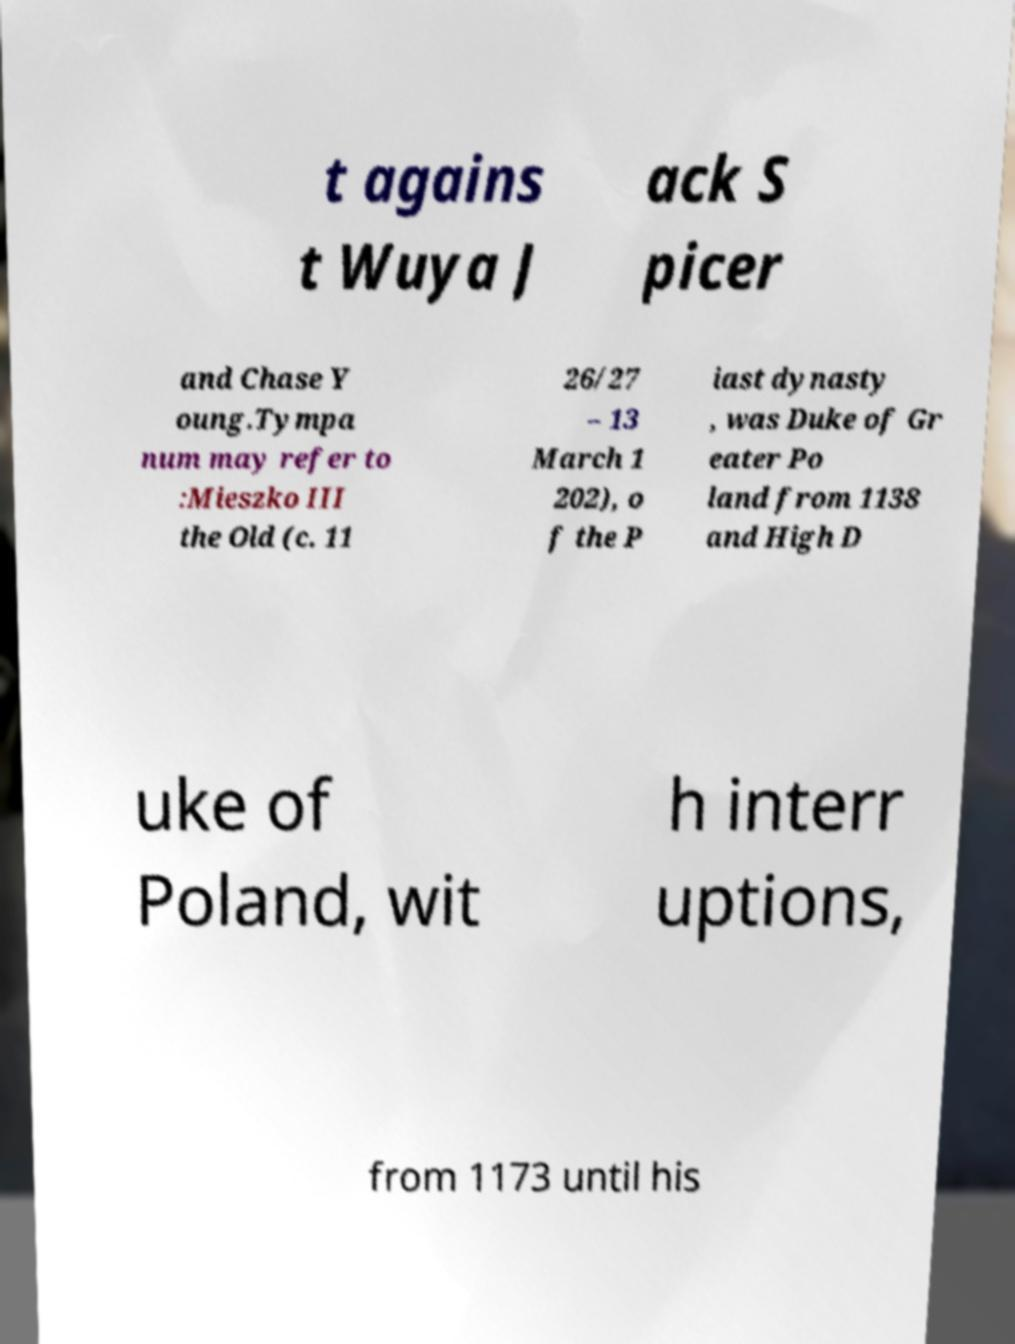Please identify and transcribe the text found in this image. t agains t Wuya J ack S picer and Chase Y oung.Tympa num may refer to :Mieszko III the Old (c. 11 26/27 – 13 March 1 202), o f the P iast dynasty , was Duke of Gr eater Po land from 1138 and High D uke of Poland, wit h interr uptions, from 1173 until his 